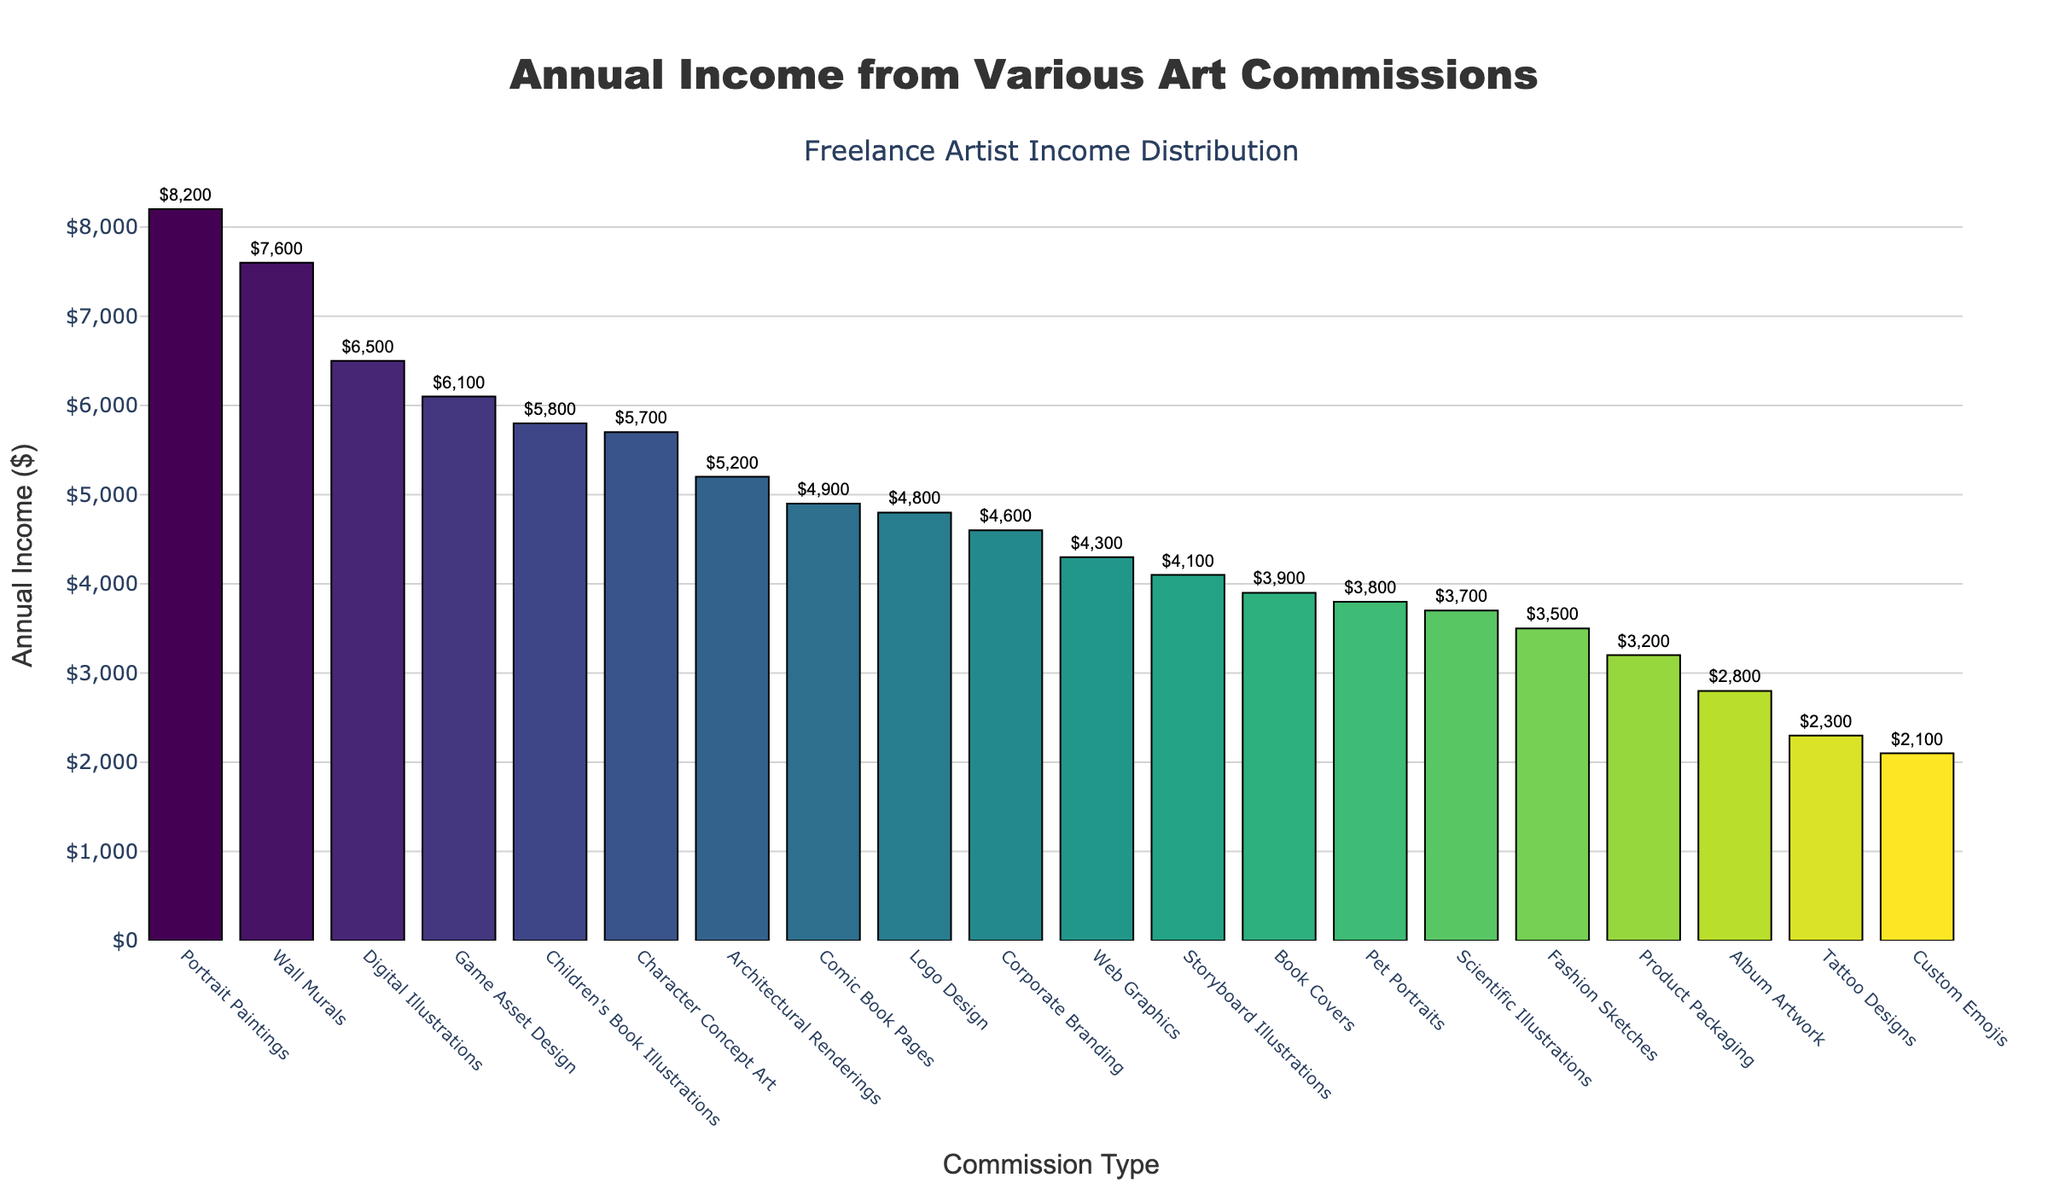Which commission type generates the highest annual income? Looking at the bar chart, identify which bar is the tallest, indicating the highest annual income. The tallest bar corresponds to Portrait Paintings.
Answer: Portrait Paintings How much more does Portrait Paintings generate compared to Digital Illustrations? Find the annual income of Portrait Paintings and Digital Illustrations from the chart (Portrait Paintings: $8,200 and Digital Illustrations: $6,500). Subtract the income of Digital Illustrations from Portrait Paintings: $8,200 - $6,500.
Answer: $1,700 What is the combined annual income from Tattoo Designs, Album Artwork, and Custom Emojis? Locate the bars for Tattoo Designs ($2,300), Album Artwork ($2,800), and Custom Emojis ($2,100). Add these amounts: $2,300 + $2,800 + $2,100.
Answer: $7,200 Which commission type generates the least annual income? Look for the shortest bar in the bar chart, which represents the lowest annual income. The shortest bar corresponds to Custom Emojis.
Answer: Custom Emojis Are Storyboard Illustrations generating more income than Book Covers? Compare the heights of the bars for Storyboard Illustrations ($4,100) and Book Covers ($3,900). Storyboard Illustrations has a higher bar than Book Covers.
Answer: Yes What is the average annual income of Web Graphics and Comic Book Pages? Find the annual incomes for Web Graphics ($4,300) and Comic Book Pages ($4,900). Sum these amounts and divide by 2 to find the average: ($4,300 + $4,900) / 2.
Answer: $4,600 How does the income from Game Asset Design compare to Character Concept Art? Check the annual incomes for Game Asset Design ($6,100) and Character Concept Art ($5,700). Since Game Asset Design’s bar is taller, it generates more income.
Answer: Game Asset Design What percentage of the total income is generated by Fashion Sketches and Product Packaging combined? Sum the incomes for Fashion Sketches ($3,500) and Product Packaging ($3,200). Then find the total of all annual incomes and calculate the percentage: ($3,500 + $3,200) / (sum of all incomes) * 100. The sum of all incomes is $83,200. The combined income is $6,700. Calculate the percentage: ($6,700 / $83,200) * 100.
Answer: 8% How much more income do Wall Murals generate compared to Scientific Illustrations? Find the annual incomes for Wall Murals ($7,600) and Scientific Illustrations ($3,700). Subtract the income of Scientific Illustrations from Wall Murals: $7,600 - $3,700.
Answer: $3,900 Which commission type has a similar annual income to Corporate Branding? Identify the bars closest in height to Corporate Branding ($4,600). The bars for Book Covers ($3,900) and Storyboard Illustrations ($4,100) are the closest.
Answer: Storyboard Illustrations 